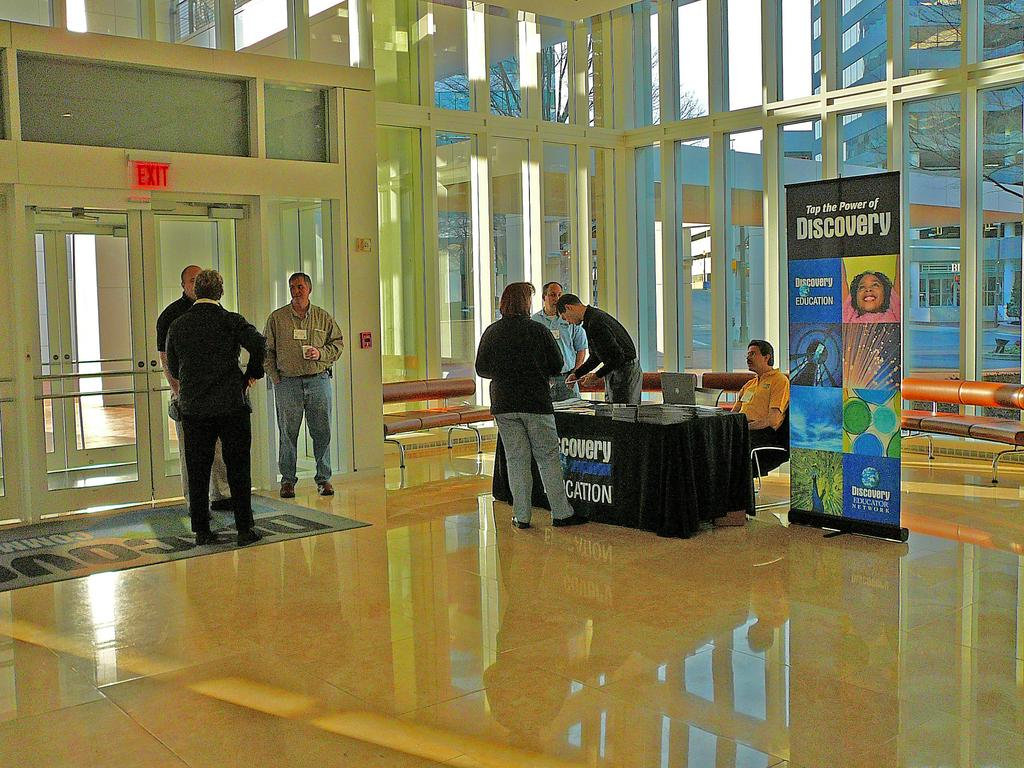How many people are present in the image? There are many people in the image. What is located in the image besides the people? There is a table in the image, and multiple items are on the table. What can be seen through the glass doors in the image? Trees and buildings are visible through the glass doors. What type of mint is being used to care for the idea in the image? There is no mint or idea present in the image; it features people, a table, items on the table, glass doors, trees, and buildings. 